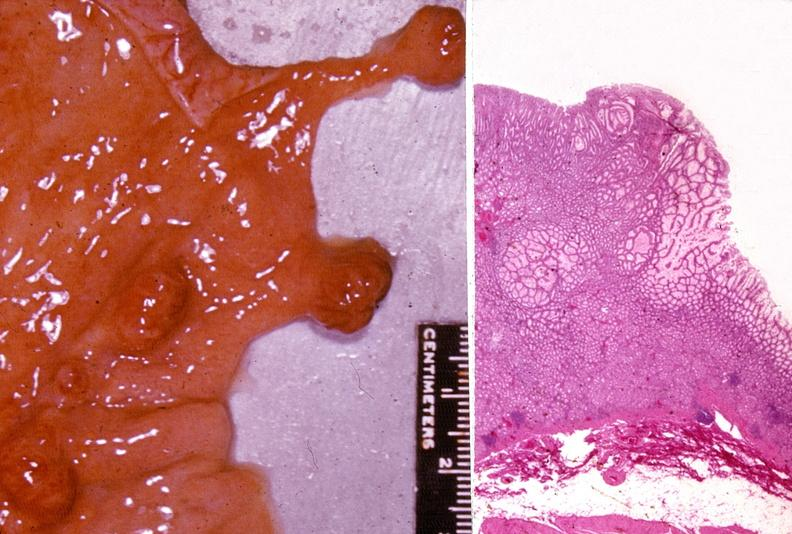does hilar cell tumor show stomach, polyposis, multiple?
Answer the question using a single word or phrase. No 